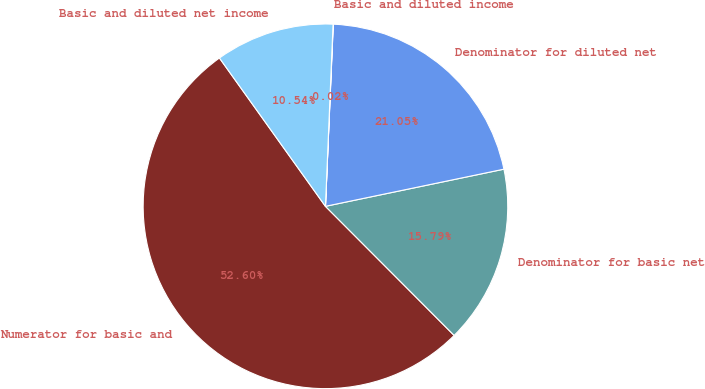Convert chart. <chart><loc_0><loc_0><loc_500><loc_500><pie_chart><fcel>Numerator for basic and<fcel>Denominator for basic net<fcel>Denominator for diluted net<fcel>Basic and diluted income<fcel>Basic and diluted net income<nl><fcel>52.6%<fcel>15.79%<fcel>21.05%<fcel>0.02%<fcel>10.54%<nl></chart> 